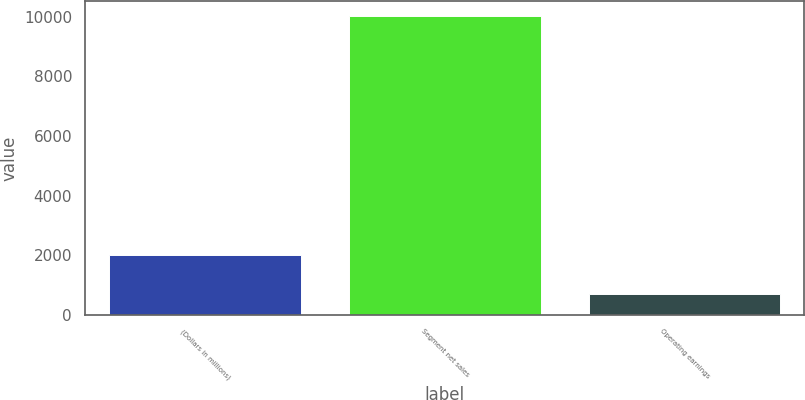<chart> <loc_0><loc_0><loc_500><loc_500><bar_chart><fcel>(Dollars in millions)<fcel>Segment net sales<fcel>Operating earnings<nl><fcel>2007<fcel>10014<fcel>709<nl></chart> 